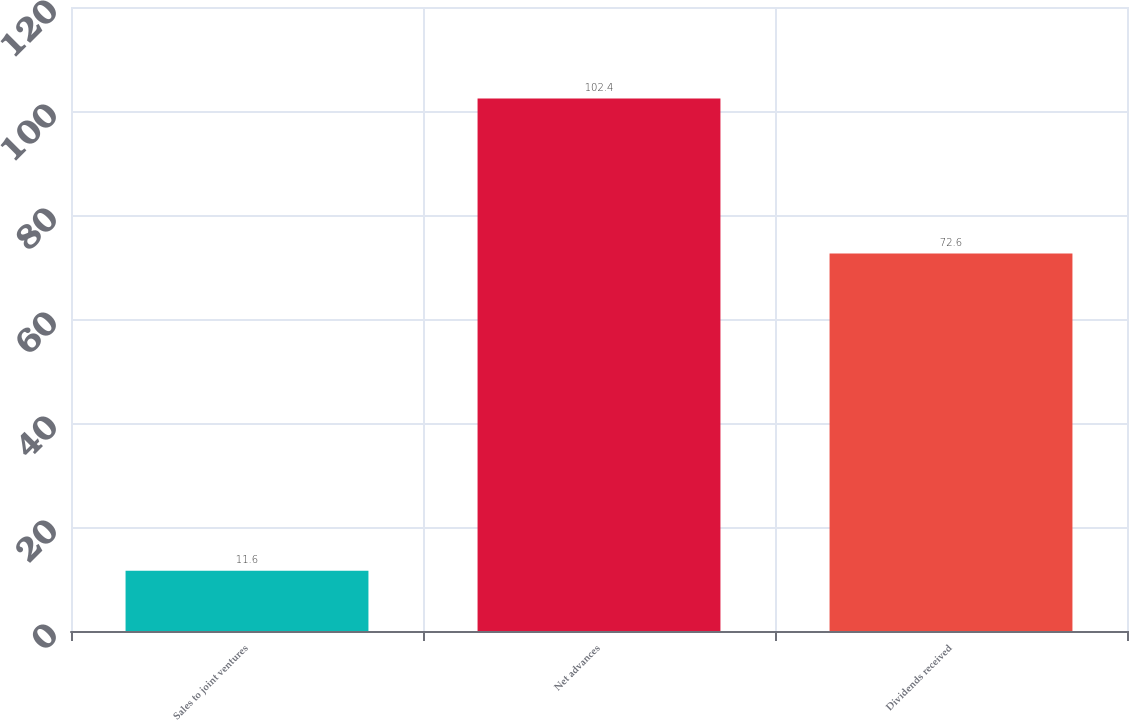Convert chart. <chart><loc_0><loc_0><loc_500><loc_500><bar_chart><fcel>Sales to joint ventures<fcel>Net advances<fcel>Dividends received<nl><fcel>11.6<fcel>102.4<fcel>72.6<nl></chart> 